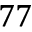<formula> <loc_0><loc_0><loc_500><loc_500>7 7</formula> 